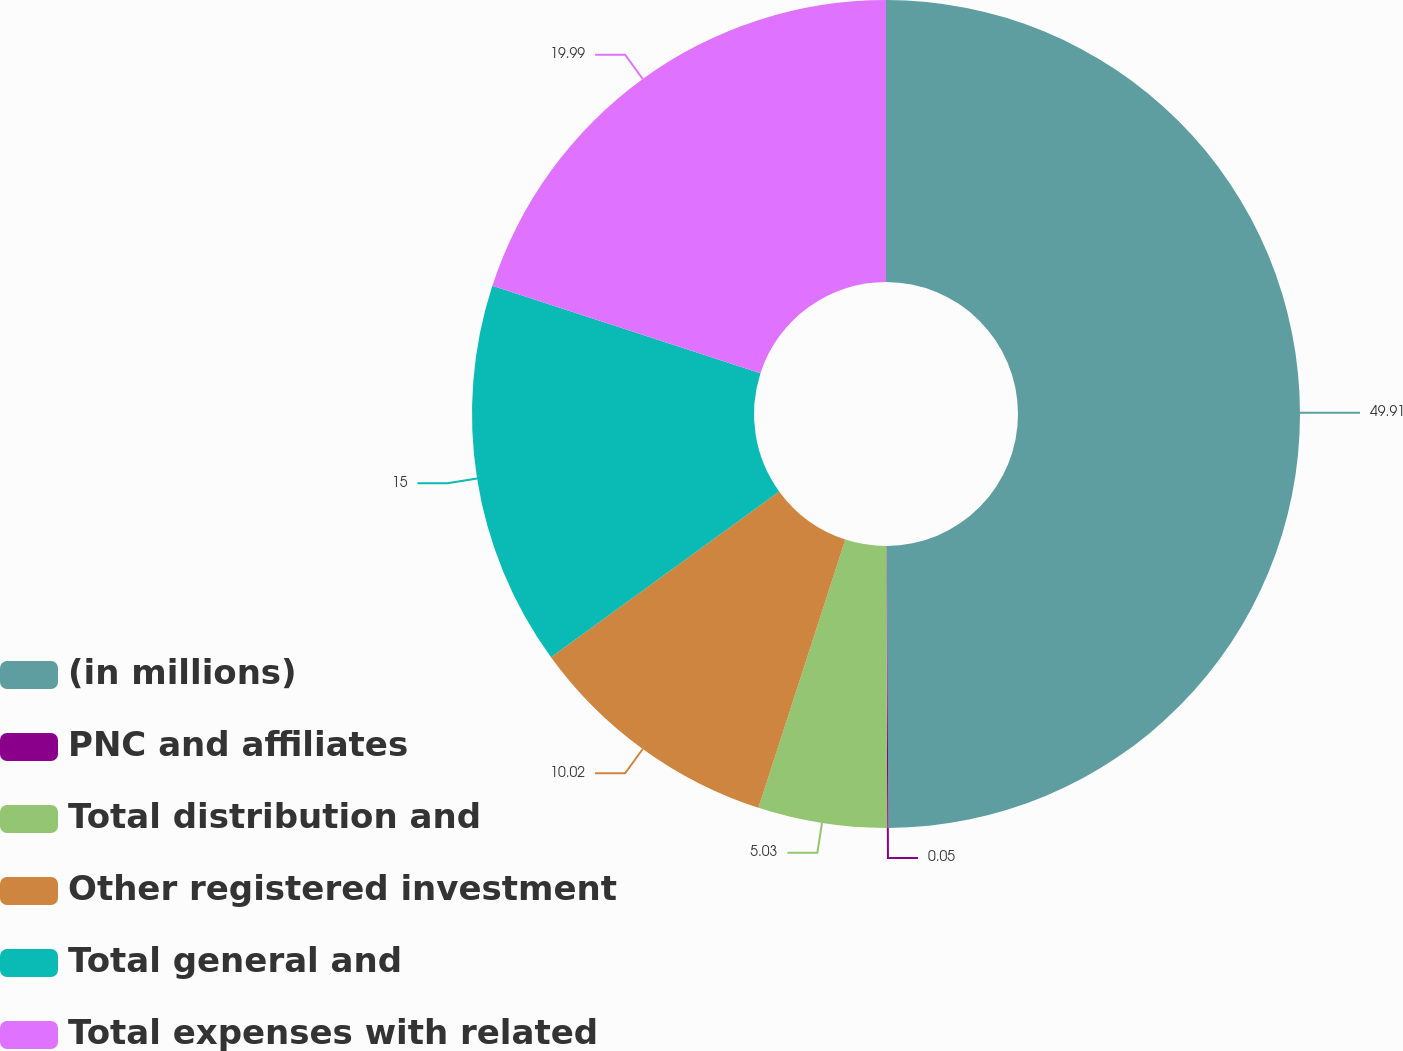Convert chart. <chart><loc_0><loc_0><loc_500><loc_500><pie_chart><fcel>(in millions)<fcel>PNC and affiliates<fcel>Total distribution and<fcel>Other registered investment<fcel>Total general and<fcel>Total expenses with related<nl><fcel>49.9%<fcel>0.05%<fcel>5.03%<fcel>10.02%<fcel>15.0%<fcel>19.99%<nl></chart> 